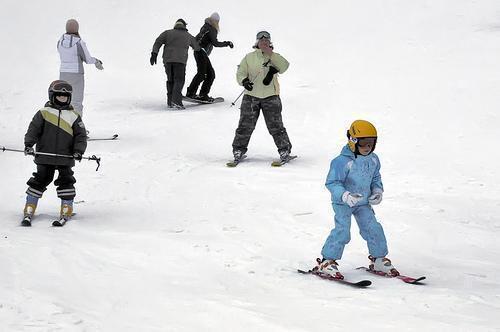What is the likely relationship of the woman to the kids?
From the following four choices, select the correct answer to address the question.
Options: Mother, sister, school principal, great grandmother. Mother. 